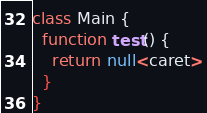Convert code to text. <code><loc_0><loc_0><loc_500><loc_500><_Haxe_>class Main {
  function test() {
    return null<caret>
  }
}</code> 